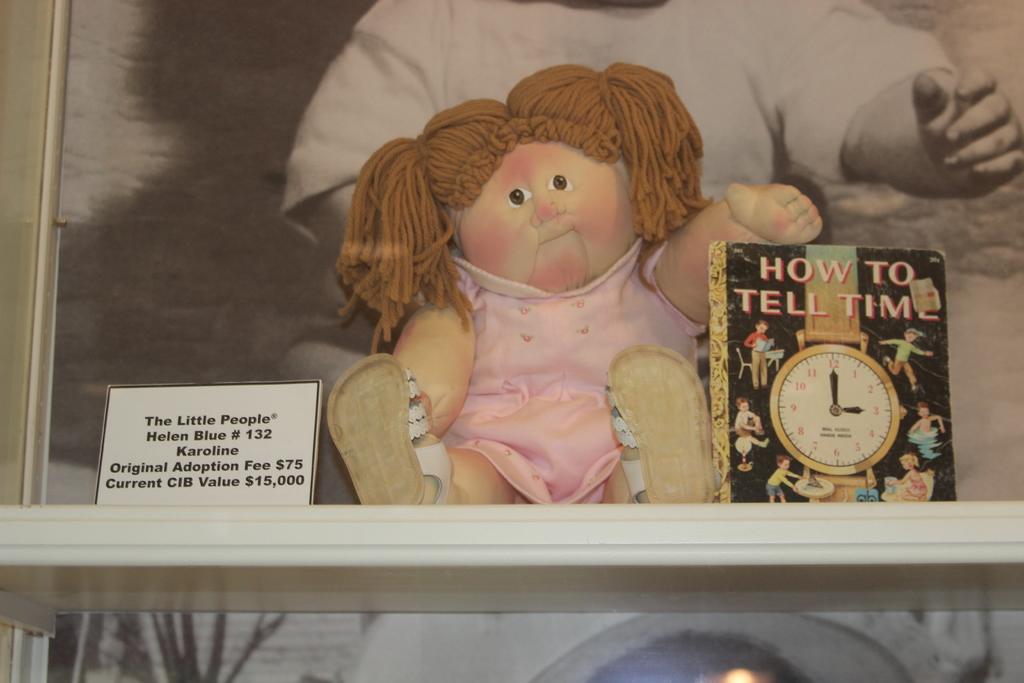What is the value of the doll?
Your response must be concise. $15,000. What is the title of the book?
Offer a very short reply. How to tell time. 